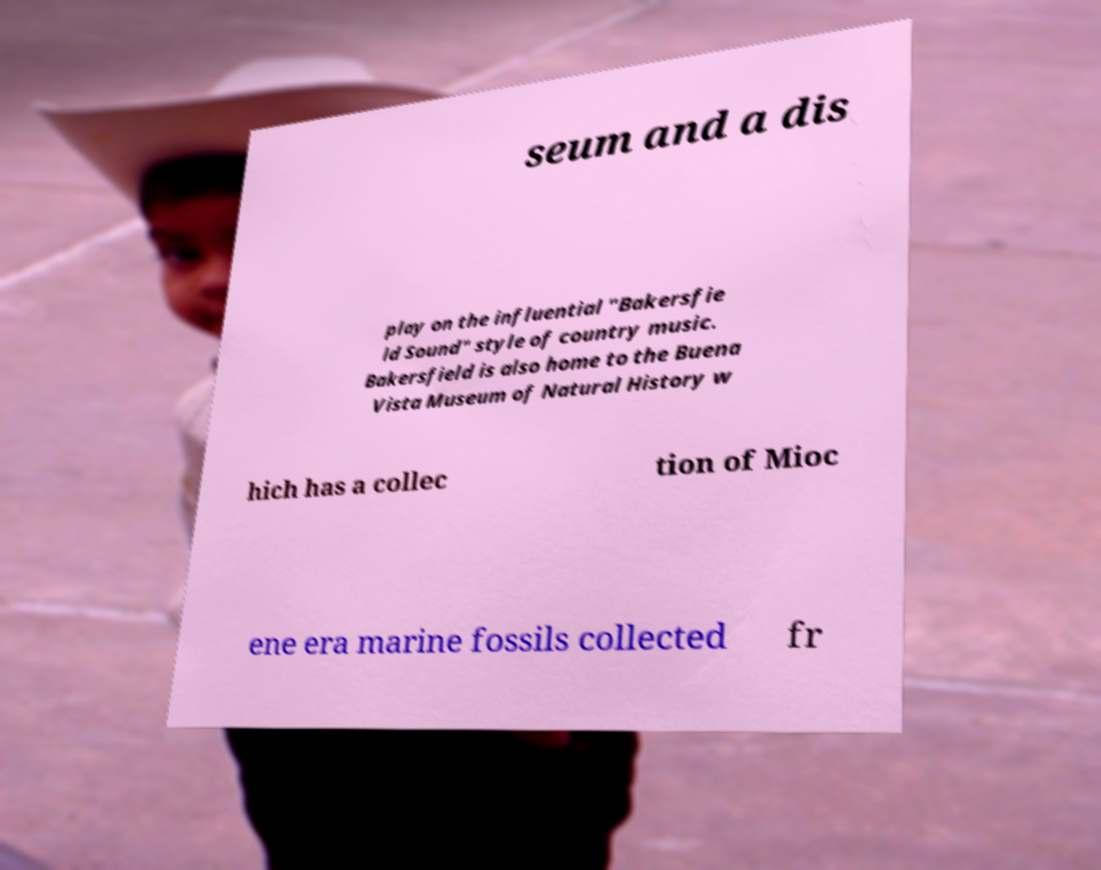For documentation purposes, I need the text within this image transcribed. Could you provide that? seum and a dis play on the influential "Bakersfie ld Sound" style of country music. Bakersfield is also home to the Buena Vista Museum of Natural History w hich has a collec tion of Mioc ene era marine fossils collected fr 